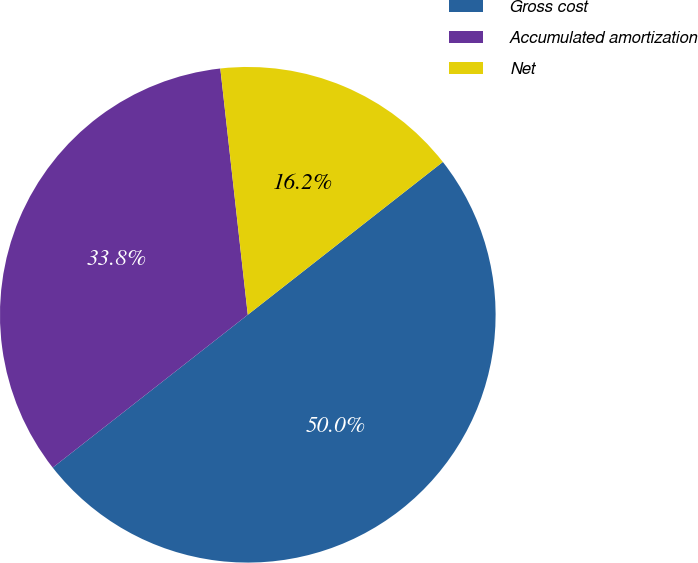Convert chart to OTSL. <chart><loc_0><loc_0><loc_500><loc_500><pie_chart><fcel>Gross cost<fcel>Accumulated amortization<fcel>Net<nl><fcel>50.0%<fcel>33.81%<fcel>16.19%<nl></chart> 